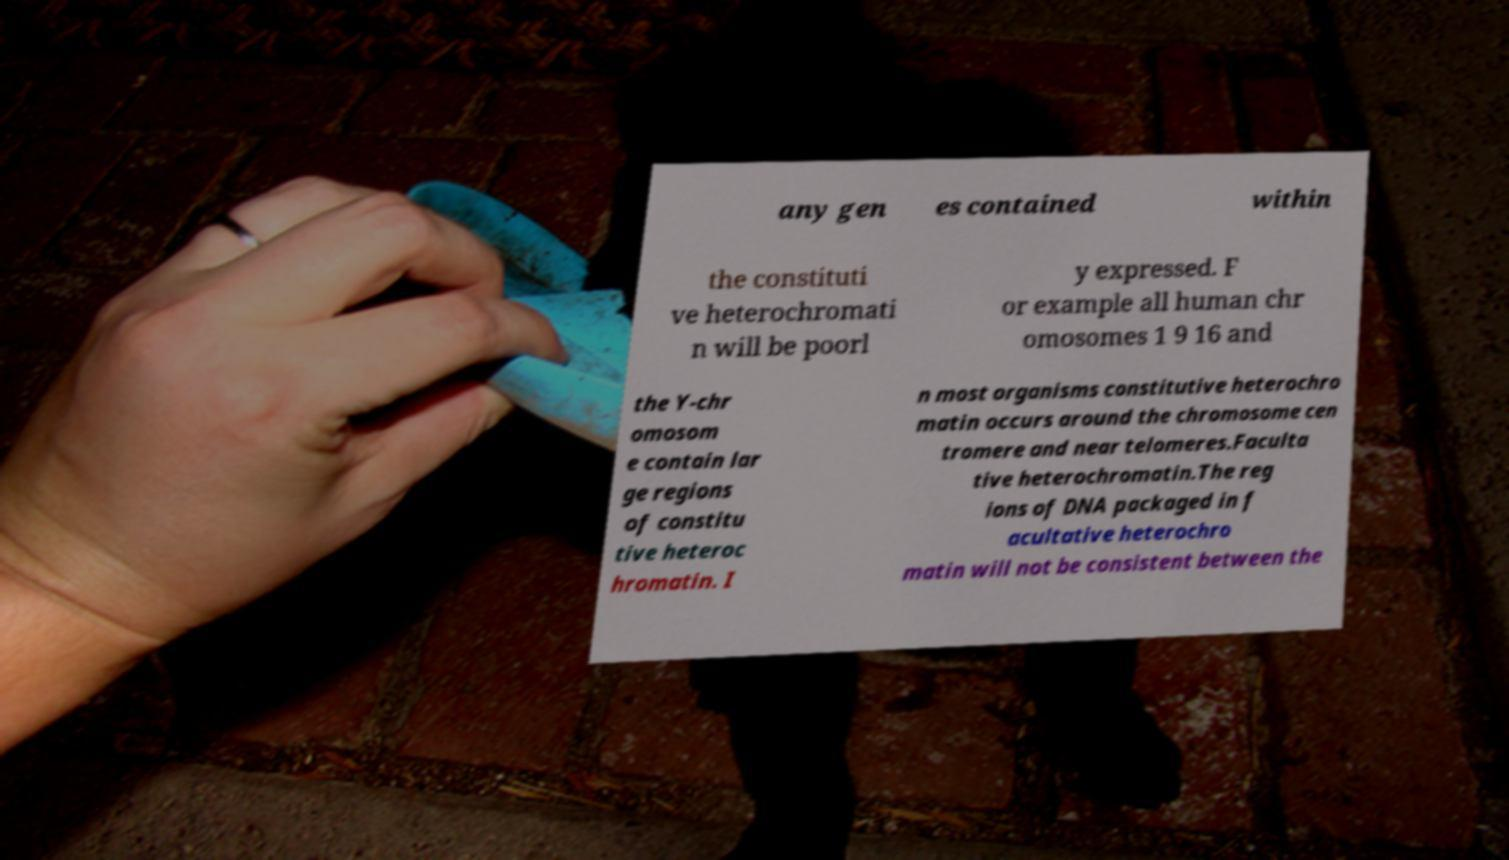There's text embedded in this image that I need extracted. Can you transcribe it verbatim? any gen es contained within the constituti ve heterochromati n will be poorl y expressed. F or example all human chr omosomes 1 9 16 and the Y-chr omosom e contain lar ge regions of constitu tive heteroc hromatin. I n most organisms constitutive heterochro matin occurs around the chromosome cen tromere and near telomeres.Faculta tive heterochromatin.The reg ions of DNA packaged in f acultative heterochro matin will not be consistent between the 